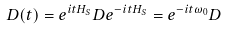<formula> <loc_0><loc_0><loc_500><loc_500>D ( t ) = e ^ { i t H _ { S } } D e ^ { - i t H _ { S } } = e ^ { - i t \omega _ { 0 } } D</formula> 